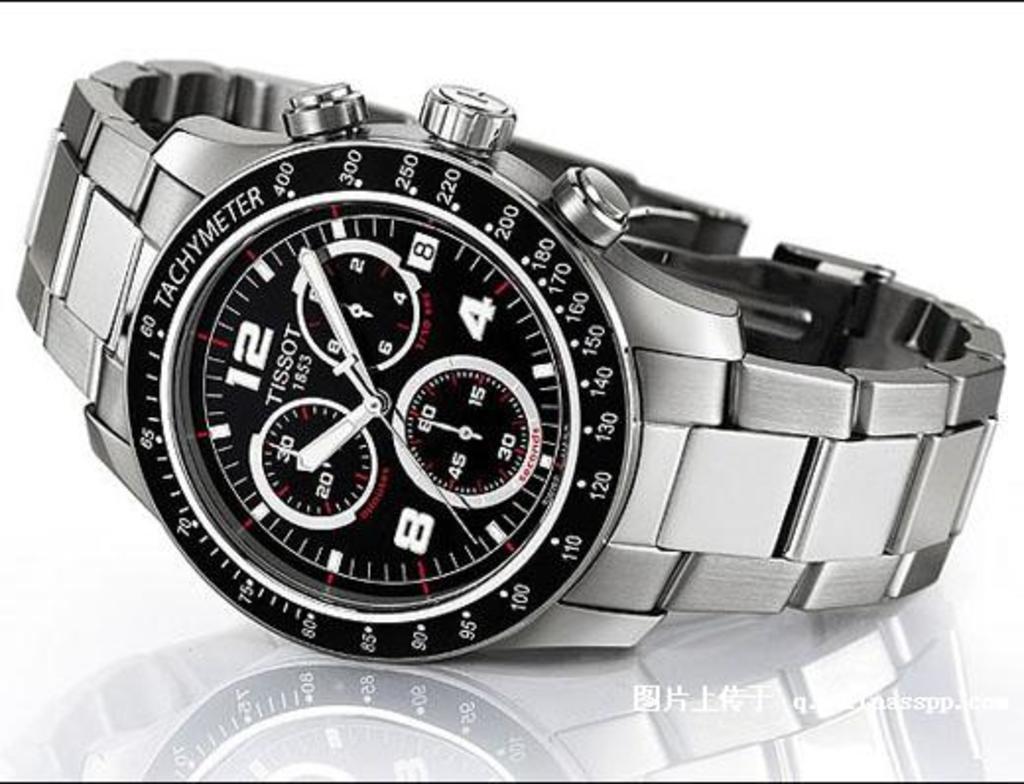Who makes this watch?
Offer a very short reply. Tissot. What type of watch is this?
Make the answer very short. Tissot. 